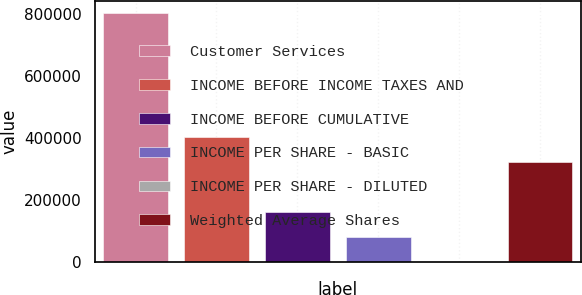Convert chart to OTSL. <chart><loc_0><loc_0><loc_500><loc_500><bar_chart><fcel>Customer Services<fcel>INCOME BEFORE INCOME TAXES AND<fcel>INCOME BEFORE CUMULATIVE<fcel>INCOME PER SHARE - BASIC<fcel>INCOME PER SHARE - DILUTED<fcel>Weighted Average Shares<nl><fcel>802417<fcel>401209<fcel>160484<fcel>80242.4<fcel>0.76<fcel>320967<nl></chart> 